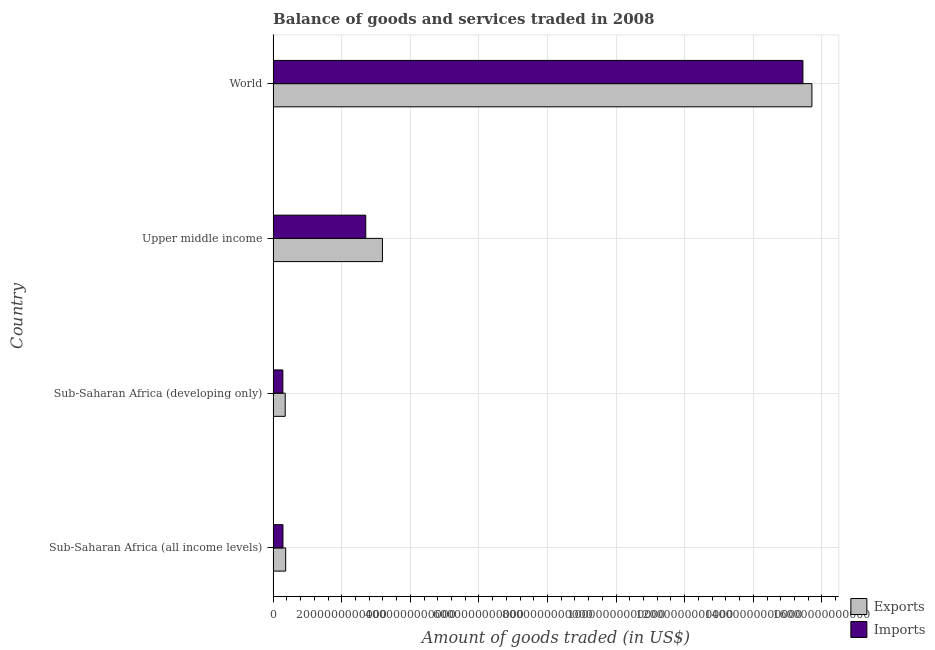How many different coloured bars are there?
Keep it short and to the point. 2. How many groups of bars are there?
Give a very brief answer. 4. How many bars are there on the 3rd tick from the bottom?
Provide a succinct answer. 2. What is the label of the 2nd group of bars from the top?
Make the answer very short. Upper middle income. What is the amount of goods exported in World?
Your answer should be very brief. 1.57e+13. Across all countries, what is the maximum amount of goods exported?
Provide a short and direct response. 1.57e+13. Across all countries, what is the minimum amount of goods exported?
Your answer should be very brief. 3.52e+11. In which country was the amount of goods imported minimum?
Your answer should be compact. Sub-Saharan Africa (developing only). What is the total amount of goods exported in the graph?
Offer a very short reply. 1.96e+13. What is the difference between the amount of goods exported in Upper middle income and that in World?
Offer a very short reply. -1.25e+13. What is the difference between the amount of goods exported in Sub-Saharan Africa (all income levels) and the amount of goods imported in Sub-Saharan Africa (developing only)?
Keep it short and to the point. 8.18e+1. What is the average amount of goods imported per country?
Your answer should be very brief. 4.68e+12. What is the difference between the amount of goods exported and amount of goods imported in Sub-Saharan Africa (all income levels)?
Offer a terse response. 7.88e+1. What is the ratio of the amount of goods exported in Sub-Saharan Africa (all income levels) to that in Sub-Saharan Africa (developing only)?
Provide a succinct answer. 1.04. What is the difference between the highest and the second highest amount of goods imported?
Your answer should be very brief. 1.27e+13. What is the difference between the highest and the lowest amount of goods imported?
Provide a short and direct response. 1.52e+13. In how many countries, is the amount of goods imported greater than the average amount of goods imported taken over all countries?
Your answer should be compact. 1. What does the 1st bar from the top in Upper middle income represents?
Keep it short and to the point. Imports. What does the 1st bar from the bottom in Upper middle income represents?
Provide a succinct answer. Exports. How many bars are there?
Make the answer very short. 8. Are all the bars in the graph horizontal?
Make the answer very short. Yes. How many countries are there in the graph?
Your response must be concise. 4. What is the difference between two consecutive major ticks on the X-axis?
Provide a succinct answer. 2.00e+12. Are the values on the major ticks of X-axis written in scientific E-notation?
Provide a succinct answer. No. How many legend labels are there?
Offer a terse response. 2. How are the legend labels stacked?
Provide a succinct answer. Vertical. What is the title of the graph?
Your answer should be compact. Balance of goods and services traded in 2008. What is the label or title of the X-axis?
Offer a terse response. Amount of goods traded (in US$). What is the label or title of the Y-axis?
Offer a terse response. Country. What is the Amount of goods traded (in US$) of Exports in Sub-Saharan Africa (all income levels)?
Ensure brevity in your answer.  3.66e+11. What is the Amount of goods traded (in US$) in Imports in Sub-Saharan Africa (all income levels)?
Provide a short and direct response. 2.87e+11. What is the Amount of goods traded (in US$) in Exports in Sub-Saharan Africa (developing only)?
Make the answer very short. 3.52e+11. What is the Amount of goods traded (in US$) in Imports in Sub-Saharan Africa (developing only)?
Your response must be concise. 2.84e+11. What is the Amount of goods traded (in US$) of Exports in Upper middle income?
Make the answer very short. 3.19e+12. What is the Amount of goods traded (in US$) in Imports in Upper middle income?
Your answer should be very brief. 2.70e+12. What is the Amount of goods traded (in US$) of Exports in World?
Your answer should be compact. 1.57e+13. What is the Amount of goods traded (in US$) in Imports in World?
Ensure brevity in your answer.  1.54e+13. Across all countries, what is the maximum Amount of goods traded (in US$) in Exports?
Provide a short and direct response. 1.57e+13. Across all countries, what is the maximum Amount of goods traded (in US$) of Imports?
Ensure brevity in your answer.  1.54e+13. Across all countries, what is the minimum Amount of goods traded (in US$) of Exports?
Your response must be concise. 3.52e+11. Across all countries, what is the minimum Amount of goods traded (in US$) of Imports?
Make the answer very short. 2.84e+11. What is the total Amount of goods traded (in US$) in Exports in the graph?
Give a very brief answer. 1.96e+13. What is the total Amount of goods traded (in US$) of Imports in the graph?
Keep it short and to the point. 1.87e+13. What is the difference between the Amount of goods traded (in US$) of Exports in Sub-Saharan Africa (all income levels) and that in Sub-Saharan Africa (developing only)?
Offer a very short reply. 1.34e+1. What is the difference between the Amount of goods traded (in US$) of Imports in Sub-Saharan Africa (all income levels) and that in Sub-Saharan Africa (developing only)?
Your answer should be very brief. 2.99e+09. What is the difference between the Amount of goods traded (in US$) in Exports in Sub-Saharan Africa (all income levels) and that in Upper middle income?
Your answer should be compact. -2.82e+12. What is the difference between the Amount of goods traded (in US$) in Imports in Sub-Saharan Africa (all income levels) and that in Upper middle income?
Your response must be concise. -2.41e+12. What is the difference between the Amount of goods traded (in US$) in Exports in Sub-Saharan Africa (all income levels) and that in World?
Provide a short and direct response. -1.53e+13. What is the difference between the Amount of goods traded (in US$) in Imports in Sub-Saharan Africa (all income levels) and that in World?
Offer a very short reply. -1.52e+13. What is the difference between the Amount of goods traded (in US$) in Exports in Sub-Saharan Africa (developing only) and that in Upper middle income?
Provide a succinct answer. -2.83e+12. What is the difference between the Amount of goods traded (in US$) in Imports in Sub-Saharan Africa (developing only) and that in Upper middle income?
Your response must be concise. -2.42e+12. What is the difference between the Amount of goods traded (in US$) of Exports in Sub-Saharan Africa (developing only) and that in World?
Your response must be concise. -1.54e+13. What is the difference between the Amount of goods traded (in US$) of Imports in Sub-Saharan Africa (developing only) and that in World?
Keep it short and to the point. -1.52e+13. What is the difference between the Amount of goods traded (in US$) in Exports in Upper middle income and that in World?
Keep it short and to the point. -1.25e+13. What is the difference between the Amount of goods traded (in US$) in Imports in Upper middle income and that in World?
Offer a terse response. -1.27e+13. What is the difference between the Amount of goods traded (in US$) of Exports in Sub-Saharan Africa (all income levels) and the Amount of goods traded (in US$) of Imports in Sub-Saharan Africa (developing only)?
Keep it short and to the point. 8.18e+1. What is the difference between the Amount of goods traded (in US$) in Exports in Sub-Saharan Africa (all income levels) and the Amount of goods traded (in US$) in Imports in Upper middle income?
Provide a short and direct response. -2.34e+12. What is the difference between the Amount of goods traded (in US$) in Exports in Sub-Saharan Africa (all income levels) and the Amount of goods traded (in US$) in Imports in World?
Offer a very short reply. -1.51e+13. What is the difference between the Amount of goods traded (in US$) of Exports in Sub-Saharan Africa (developing only) and the Amount of goods traded (in US$) of Imports in Upper middle income?
Offer a terse response. -2.35e+12. What is the difference between the Amount of goods traded (in US$) in Exports in Sub-Saharan Africa (developing only) and the Amount of goods traded (in US$) in Imports in World?
Make the answer very short. -1.51e+13. What is the difference between the Amount of goods traded (in US$) in Exports in Upper middle income and the Amount of goods traded (in US$) in Imports in World?
Give a very brief answer. -1.23e+13. What is the average Amount of goods traded (in US$) of Exports per country?
Give a very brief answer. 4.90e+12. What is the average Amount of goods traded (in US$) of Imports per country?
Make the answer very short. 4.68e+12. What is the difference between the Amount of goods traded (in US$) in Exports and Amount of goods traded (in US$) in Imports in Sub-Saharan Africa (all income levels)?
Your response must be concise. 7.88e+1. What is the difference between the Amount of goods traded (in US$) of Exports and Amount of goods traded (in US$) of Imports in Sub-Saharan Africa (developing only)?
Your response must be concise. 6.84e+1. What is the difference between the Amount of goods traded (in US$) in Exports and Amount of goods traded (in US$) in Imports in Upper middle income?
Offer a terse response. 4.86e+11. What is the difference between the Amount of goods traded (in US$) in Exports and Amount of goods traded (in US$) in Imports in World?
Ensure brevity in your answer.  2.62e+11. What is the ratio of the Amount of goods traded (in US$) in Exports in Sub-Saharan Africa (all income levels) to that in Sub-Saharan Africa (developing only)?
Your answer should be compact. 1.04. What is the ratio of the Amount of goods traded (in US$) in Imports in Sub-Saharan Africa (all income levels) to that in Sub-Saharan Africa (developing only)?
Offer a terse response. 1.01. What is the ratio of the Amount of goods traded (in US$) in Exports in Sub-Saharan Africa (all income levels) to that in Upper middle income?
Provide a succinct answer. 0.11. What is the ratio of the Amount of goods traded (in US$) in Imports in Sub-Saharan Africa (all income levels) to that in Upper middle income?
Keep it short and to the point. 0.11. What is the ratio of the Amount of goods traded (in US$) of Exports in Sub-Saharan Africa (all income levels) to that in World?
Offer a very short reply. 0.02. What is the ratio of the Amount of goods traded (in US$) in Imports in Sub-Saharan Africa (all income levels) to that in World?
Your answer should be very brief. 0.02. What is the ratio of the Amount of goods traded (in US$) of Exports in Sub-Saharan Africa (developing only) to that in Upper middle income?
Offer a very short reply. 0.11. What is the ratio of the Amount of goods traded (in US$) in Imports in Sub-Saharan Africa (developing only) to that in Upper middle income?
Provide a short and direct response. 0.11. What is the ratio of the Amount of goods traded (in US$) of Exports in Sub-Saharan Africa (developing only) to that in World?
Provide a short and direct response. 0.02. What is the ratio of the Amount of goods traded (in US$) of Imports in Sub-Saharan Africa (developing only) to that in World?
Give a very brief answer. 0.02. What is the ratio of the Amount of goods traded (in US$) in Exports in Upper middle income to that in World?
Provide a succinct answer. 0.2. What is the ratio of the Amount of goods traded (in US$) in Imports in Upper middle income to that in World?
Your answer should be compact. 0.17. What is the difference between the highest and the second highest Amount of goods traded (in US$) in Exports?
Provide a short and direct response. 1.25e+13. What is the difference between the highest and the second highest Amount of goods traded (in US$) in Imports?
Give a very brief answer. 1.27e+13. What is the difference between the highest and the lowest Amount of goods traded (in US$) in Exports?
Your answer should be compact. 1.54e+13. What is the difference between the highest and the lowest Amount of goods traded (in US$) of Imports?
Offer a terse response. 1.52e+13. 